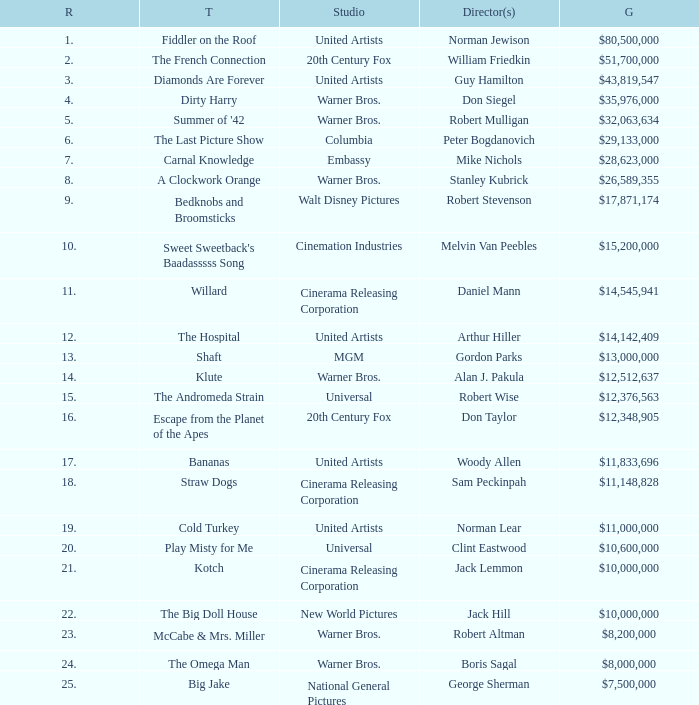What rank is the title with a gross of $26,589,355? 8.0. 